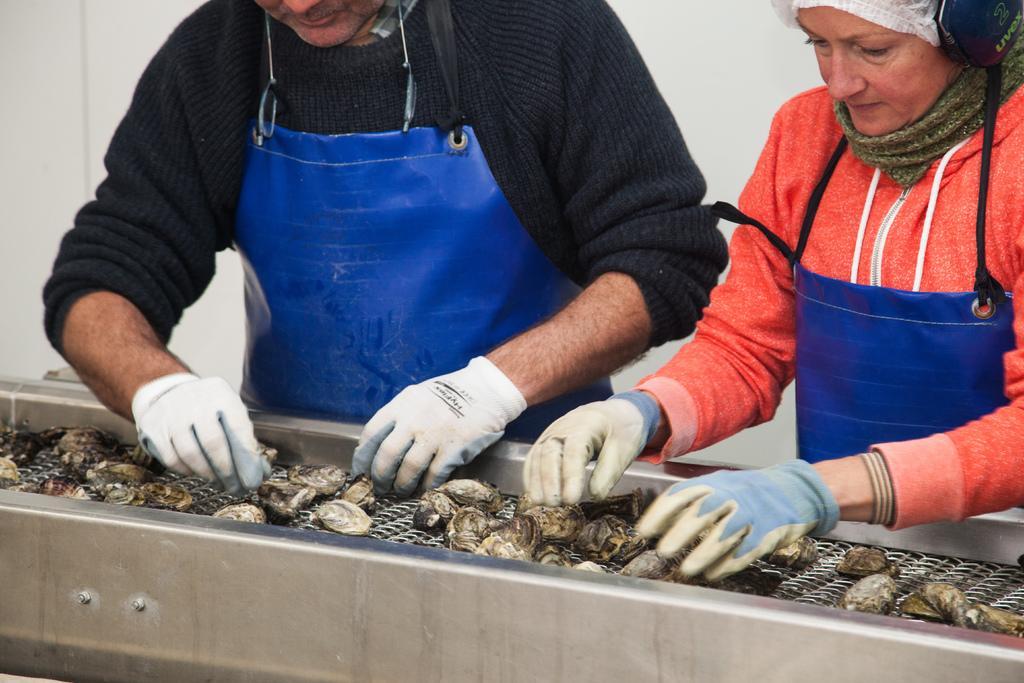How would you summarize this image in a sentence or two? In this image I can see two persons standing and wearing gloves. There are cockles on an object. 